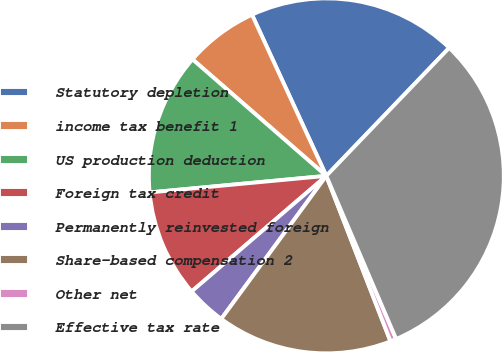<chart> <loc_0><loc_0><loc_500><loc_500><pie_chart><fcel>Statutory depletion<fcel>income tax benefit 1<fcel>US production deduction<fcel>Foreign tax credit<fcel>Permanently reinvested foreign<fcel>Share-based compensation 2<fcel>Other net<fcel>Effective tax rate<nl><fcel>19.05%<fcel>6.72%<fcel>12.89%<fcel>9.8%<fcel>3.63%<fcel>15.97%<fcel>0.55%<fcel>31.39%<nl></chart> 